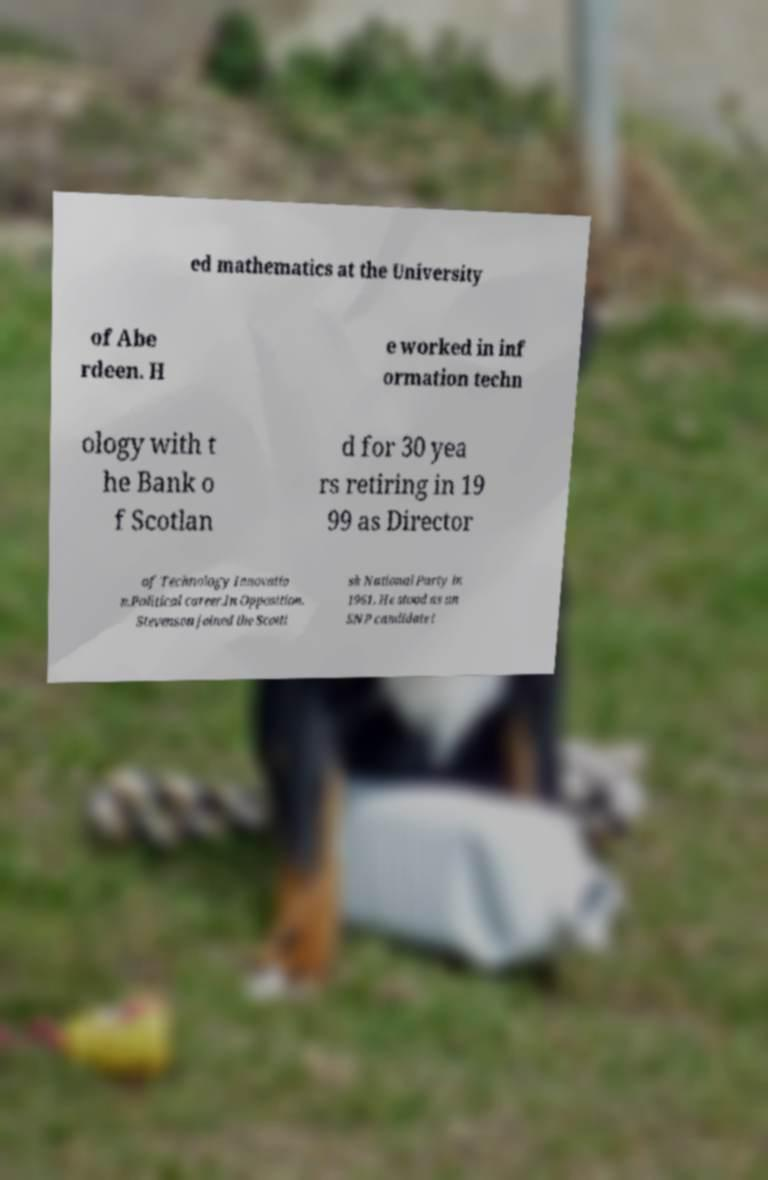Please identify and transcribe the text found in this image. ed mathematics at the University of Abe rdeen. H e worked in inf ormation techn ology with t he Bank o f Scotlan d for 30 yea rs retiring in 19 99 as Director of Technology Innovatio n.Political career.In Opposition. Stevenson joined the Scotti sh National Party in 1961. He stood as an SNP candidate i 